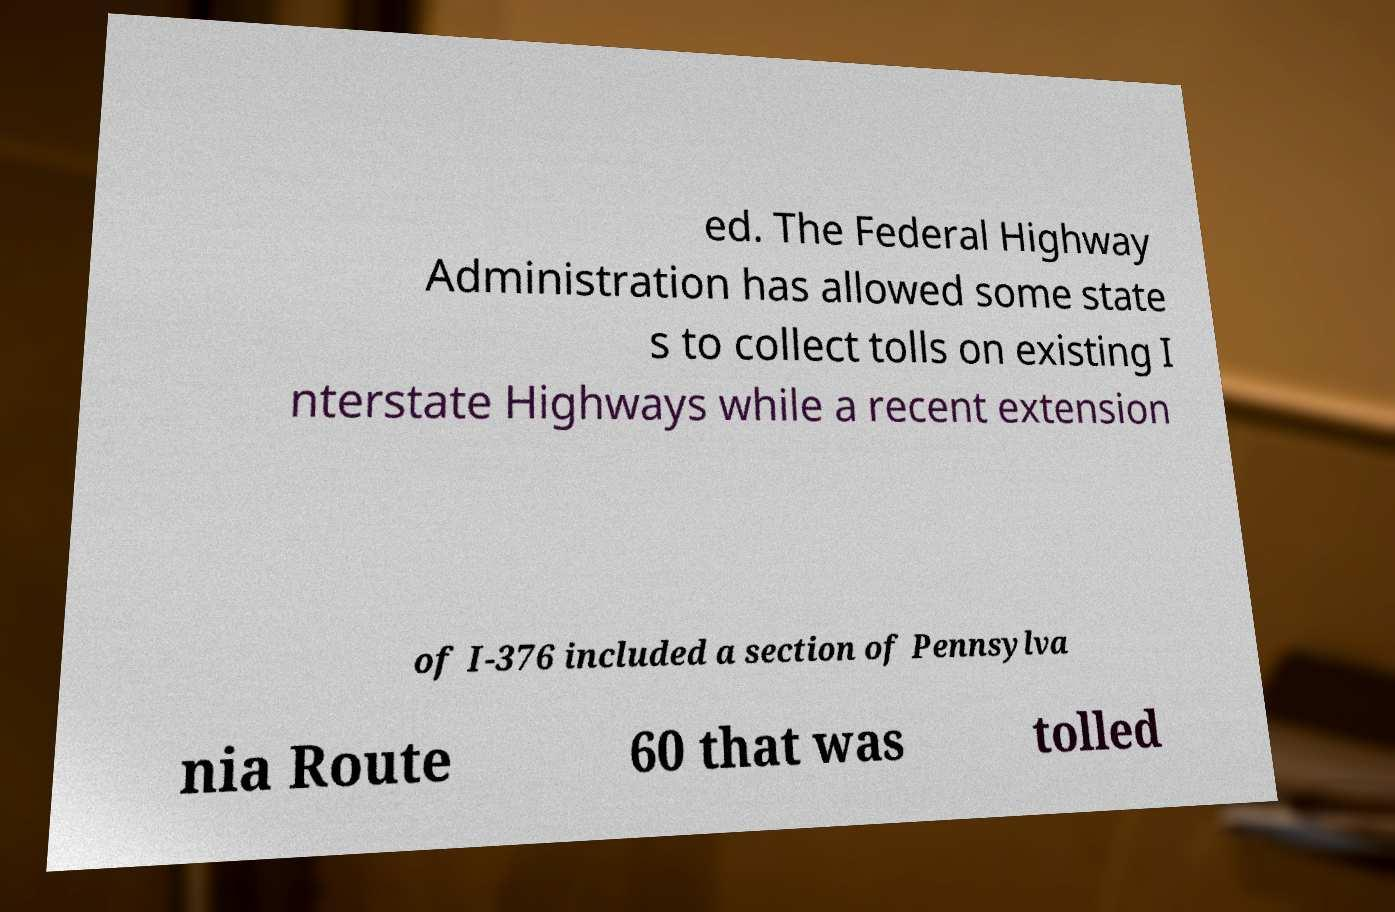Please read and relay the text visible in this image. What does it say? ed. The Federal Highway Administration has allowed some state s to collect tolls on existing I nterstate Highways while a recent extension of I-376 included a section of Pennsylva nia Route 60 that was tolled 